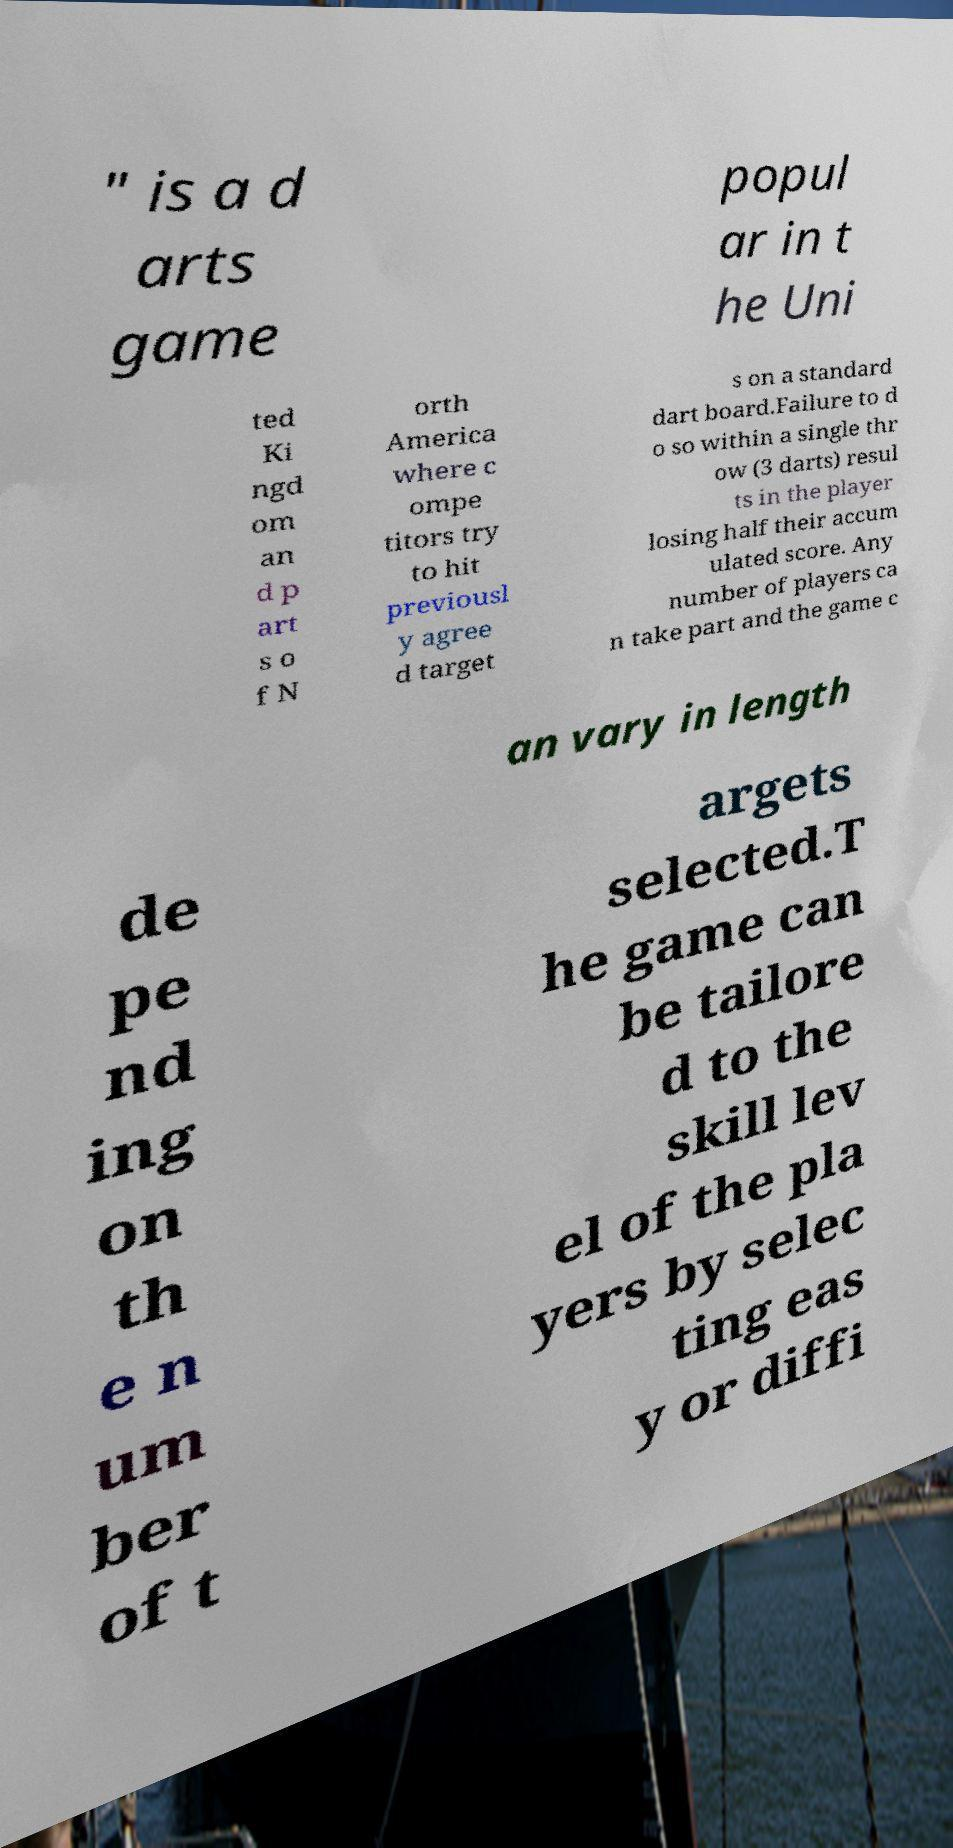What messages or text are displayed in this image? I need them in a readable, typed format. " is a d arts game popul ar in t he Uni ted Ki ngd om an d p art s o f N orth America where c ompe titors try to hit previousl y agree d target s on a standard dart board.Failure to d o so within a single thr ow (3 darts) resul ts in the player losing half their accum ulated score. Any number of players ca n take part and the game c an vary in length de pe nd ing on th e n um ber of t argets selected.T he game can be tailore d to the skill lev el of the pla yers by selec ting eas y or diffi 